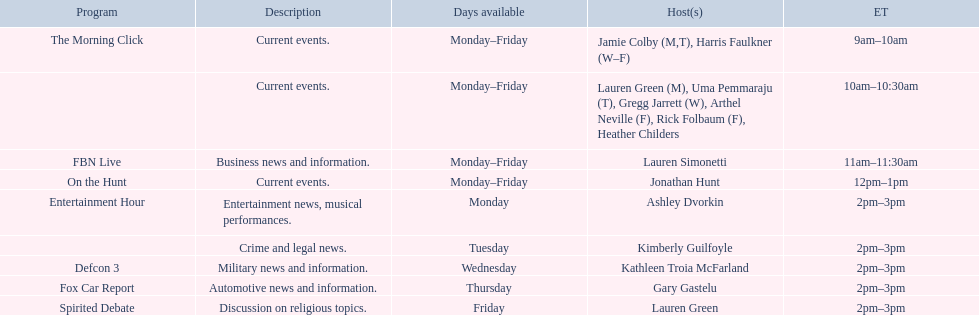What are the names of all the hosts? Jamie Colby (M,T), Harris Faulkner (W–F), Lauren Green (M), Uma Pemmaraju (T), Gregg Jarrett (W), Arthel Neville (F), Rick Folbaum (F), Heather Childers, Lauren Simonetti, Jonathan Hunt, Ashley Dvorkin, Kimberly Guilfoyle, Kathleen Troia McFarland, Gary Gastelu, Lauren Green. What hosts have a show on friday? Jamie Colby (M,T), Harris Faulkner (W–F), Lauren Green (M), Uma Pemmaraju (T), Gregg Jarrett (W), Arthel Neville (F), Rick Folbaum (F), Heather Childers, Lauren Simonetti, Jonathan Hunt, Lauren Green. Of these hosts, which is the only host with only friday available? Lauren Green. 